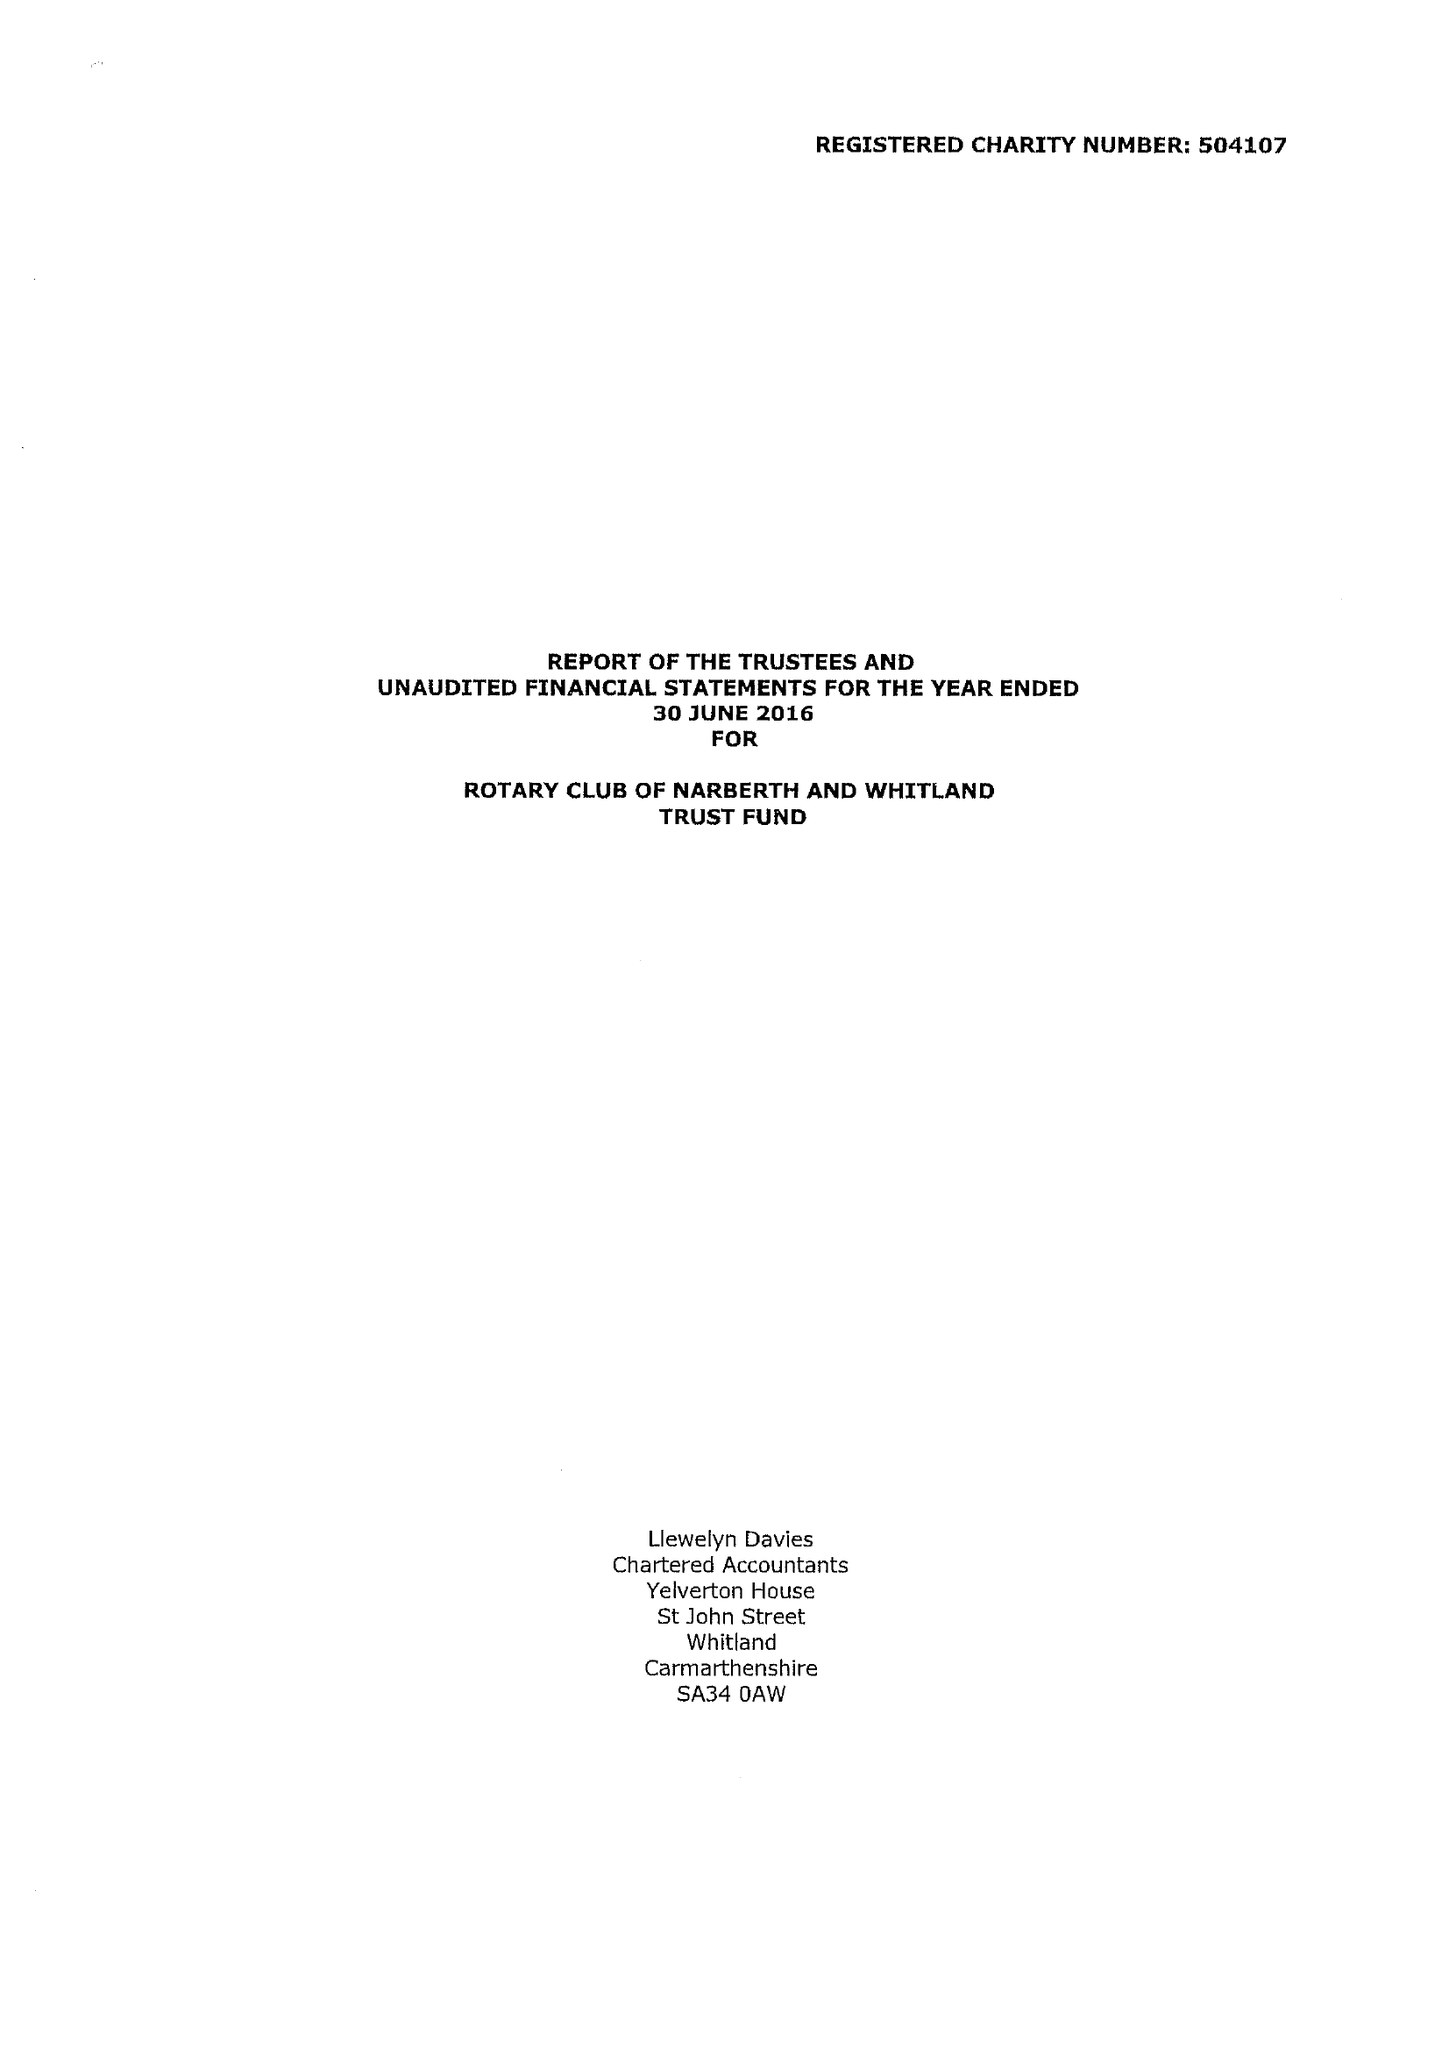What is the value for the address__post_town?
Answer the question using a single word or phrase. NARBERTH 